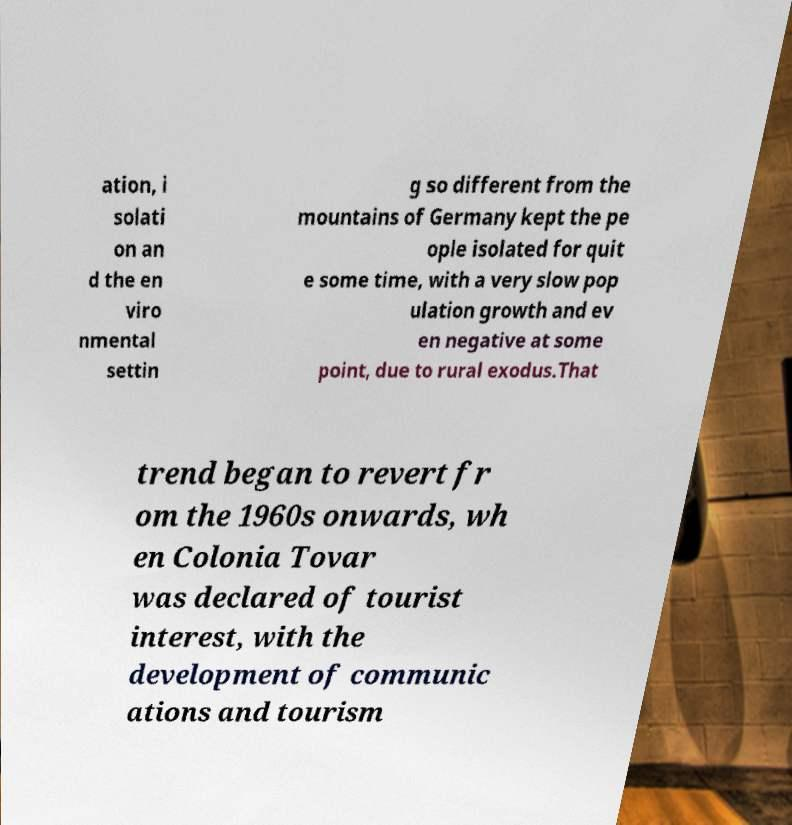Could you assist in decoding the text presented in this image and type it out clearly? ation, i solati on an d the en viro nmental settin g so different from the mountains of Germany kept the pe ople isolated for quit e some time, with a very slow pop ulation growth and ev en negative at some point, due to rural exodus.That trend began to revert fr om the 1960s onwards, wh en Colonia Tovar was declared of tourist interest, with the development of communic ations and tourism 